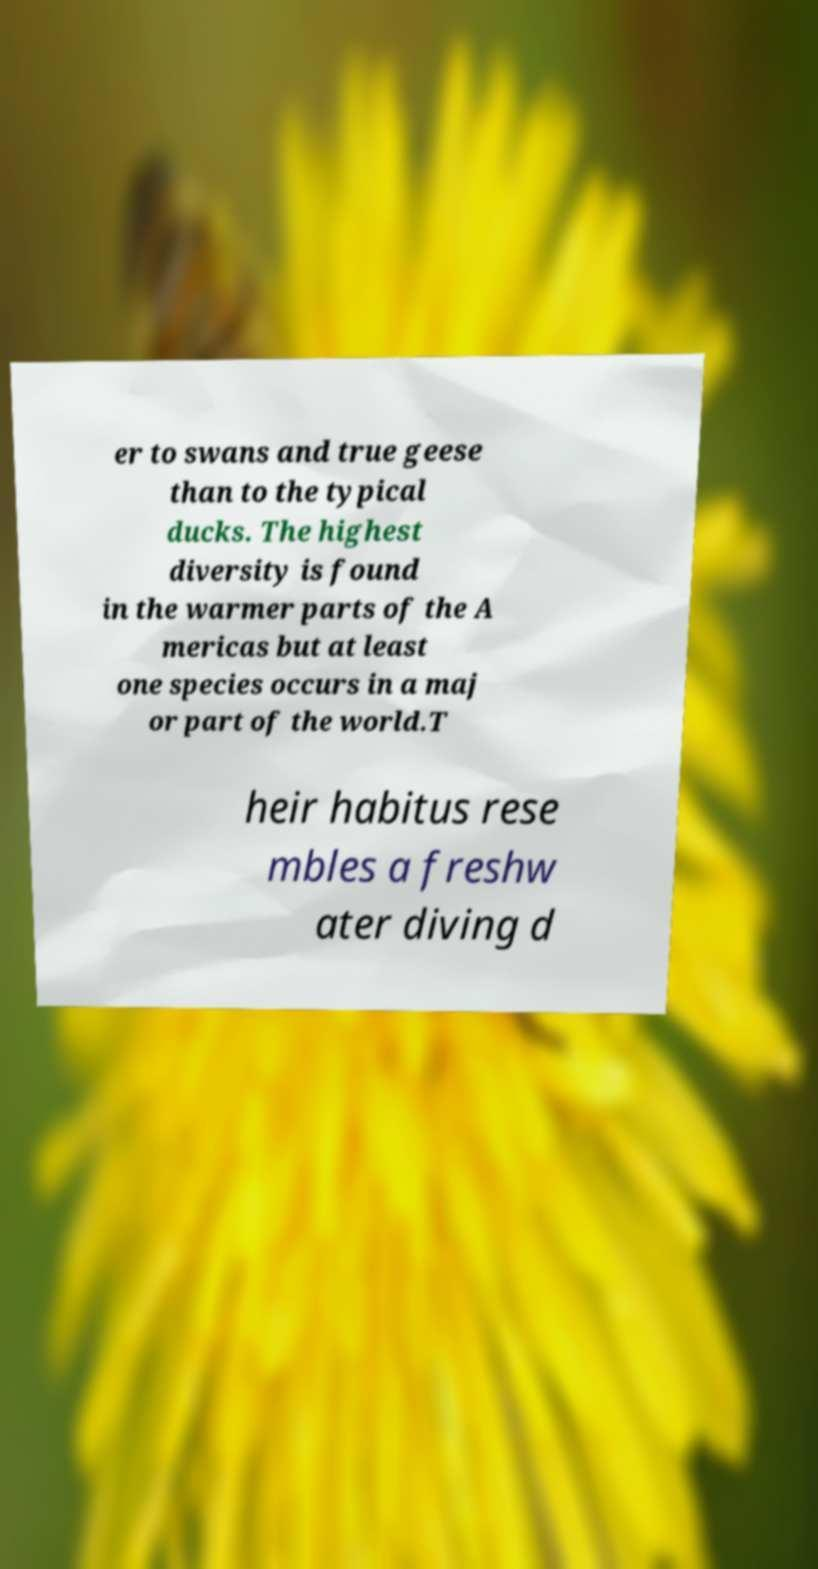I need the written content from this picture converted into text. Can you do that? er to swans and true geese than to the typical ducks. The highest diversity is found in the warmer parts of the A mericas but at least one species occurs in a maj or part of the world.T heir habitus rese mbles a freshw ater diving d 